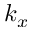Convert formula to latex. <formula><loc_0><loc_0><loc_500><loc_500>k _ { x }</formula> 